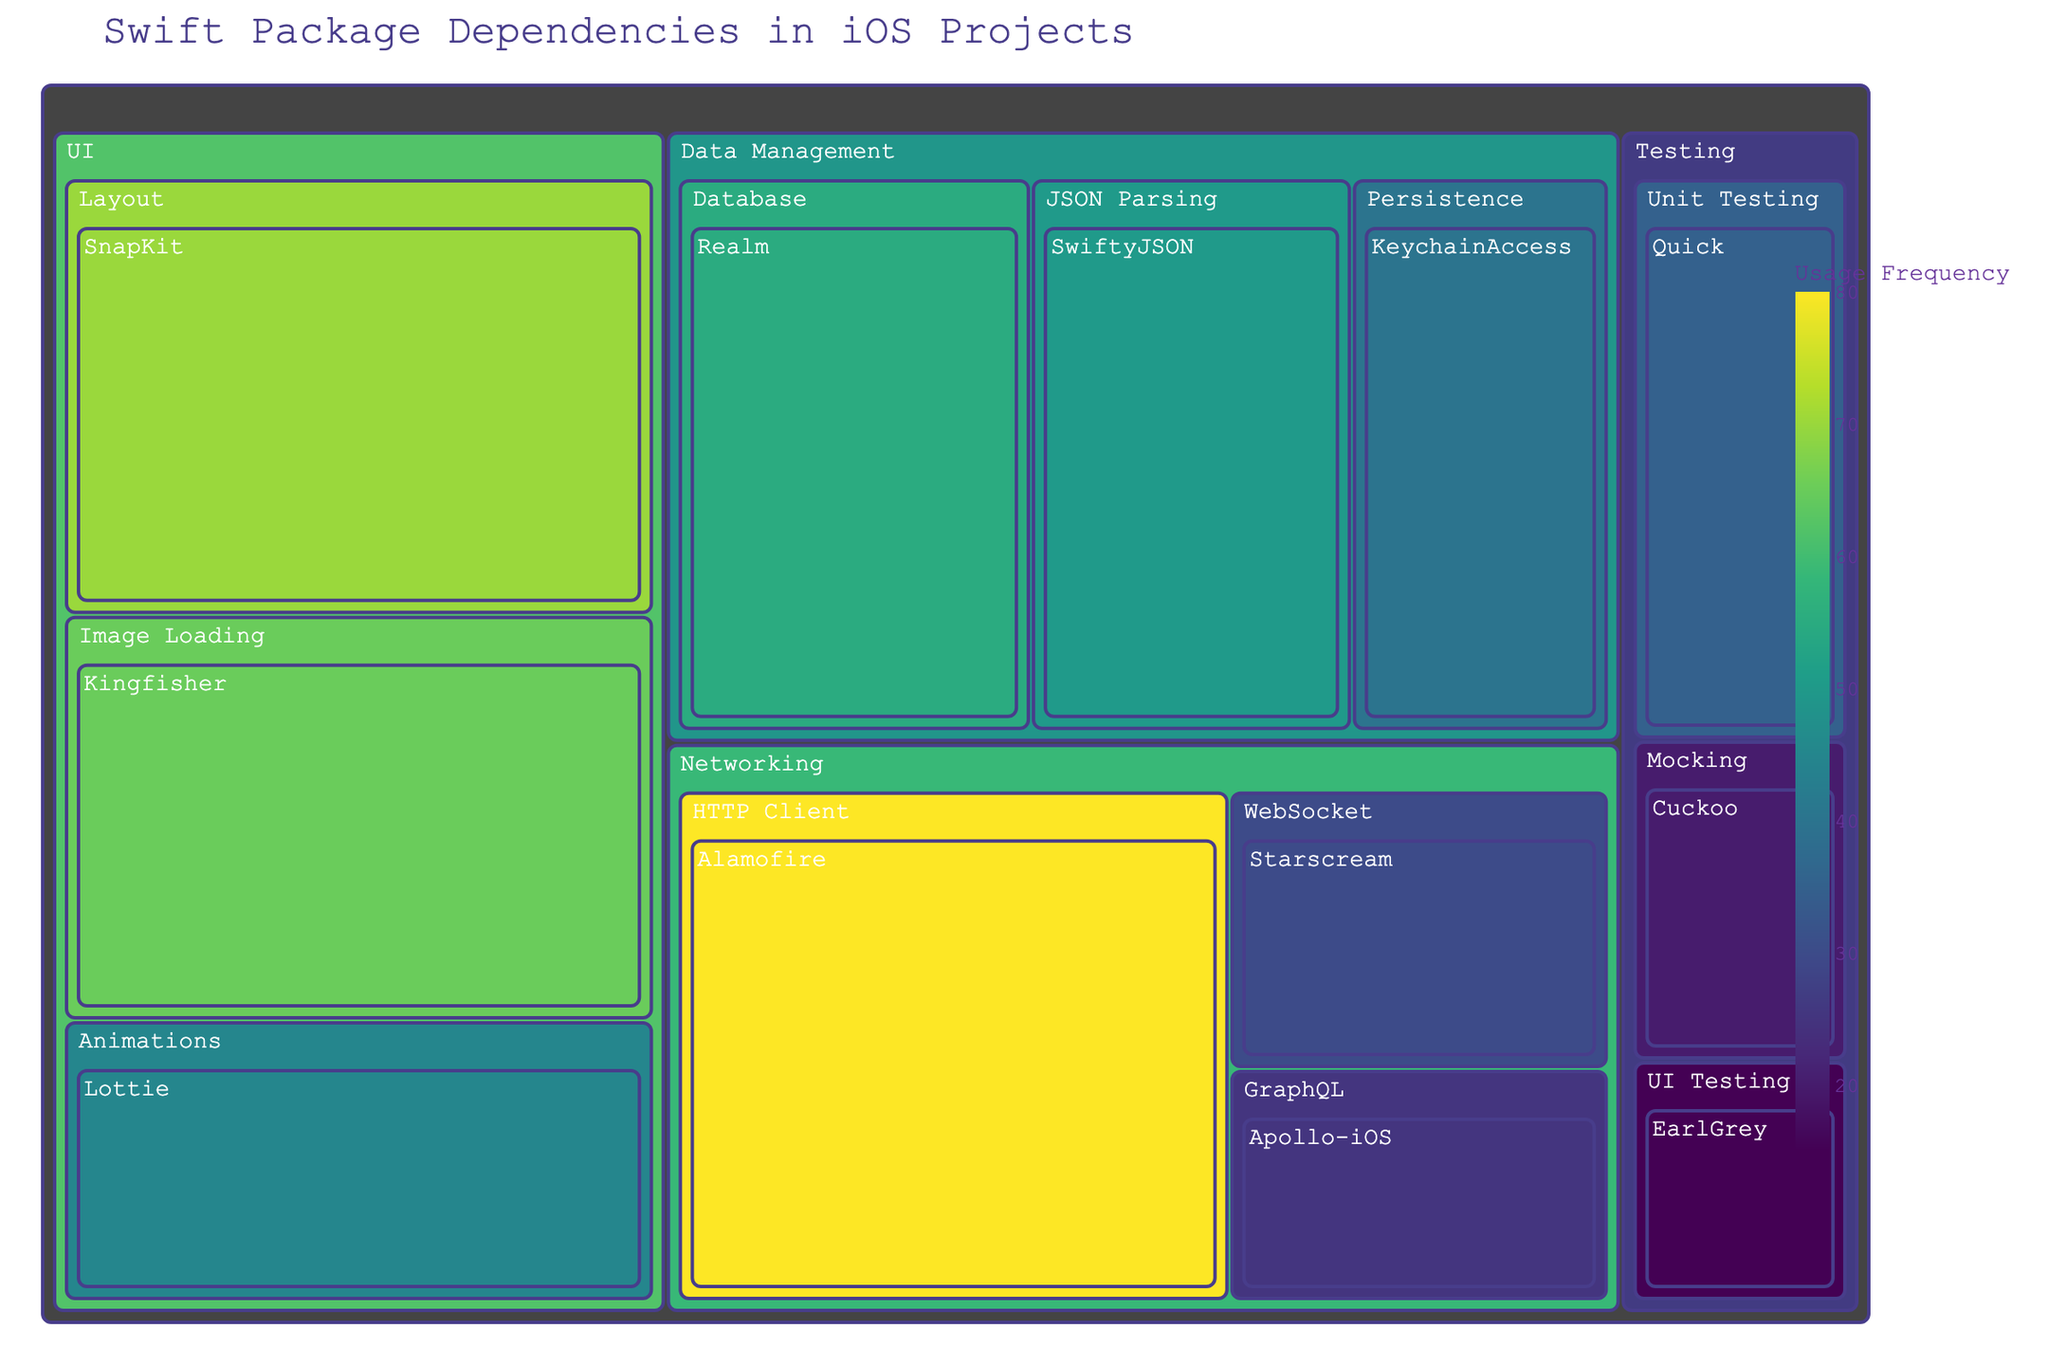What is the title of the treemap? The title of the treemap is usually located at the top center of the figure and is displayed in a larger font size. It summarizes the main topic or focus of the figure.
Answer: Swift Package Dependencies in iOS Projects How many subcategories belong to the 'Networking' category? To find the number of subcategories, look under the 'Networking' category box. Each smaller box within 'Networking' represents one subcategory.
Answer: 3 Which package under the 'UI' category has the highest usage frequency? Within the 'UI' category, identify the box with the highest numerical value representing usage frequency.
Answer: SnapKit What is the total usage frequency of all packages under the 'Testing' category? Add the usage numbers for each package within the 'Testing' category: Quick (35), Cuckoo (20), EarlGrey (15). Thus, 35 + 20 + 15 = 70.
Answer: 70 Compare the usage frequencies of 'Kingfisher' and 'SwiftyJSON'. Which one is more frequently used? Locate the usage frequencies of both 'Kingfisher' and 'SwiftyJSON'. Compare their values. Kingfisher has 65, and SwiftyJSON has 50.
Answer: Kingfisher What is the average usage frequency of packages in the 'UI' category? To find the average, sum the usage frequencies of all UI packages: SnapKit (70), Lottie (45), Kingfisher (65). The total is 70 + 45 + 65 = 180. Divide by the number of packages (3). 180 / 3 = 60.
Answer: 60 Which 'Data Management' package is used the least? Identify the package within the 'Data Management' category with the smallest numerical usage frequency.
Answer: KeychainAccess 